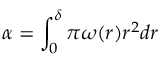<formula> <loc_0><loc_0><loc_500><loc_500>\alpha = \int _ { 0 } ^ { \delta } \pi \omega ( r ) r ^ { 2 } d r</formula> 